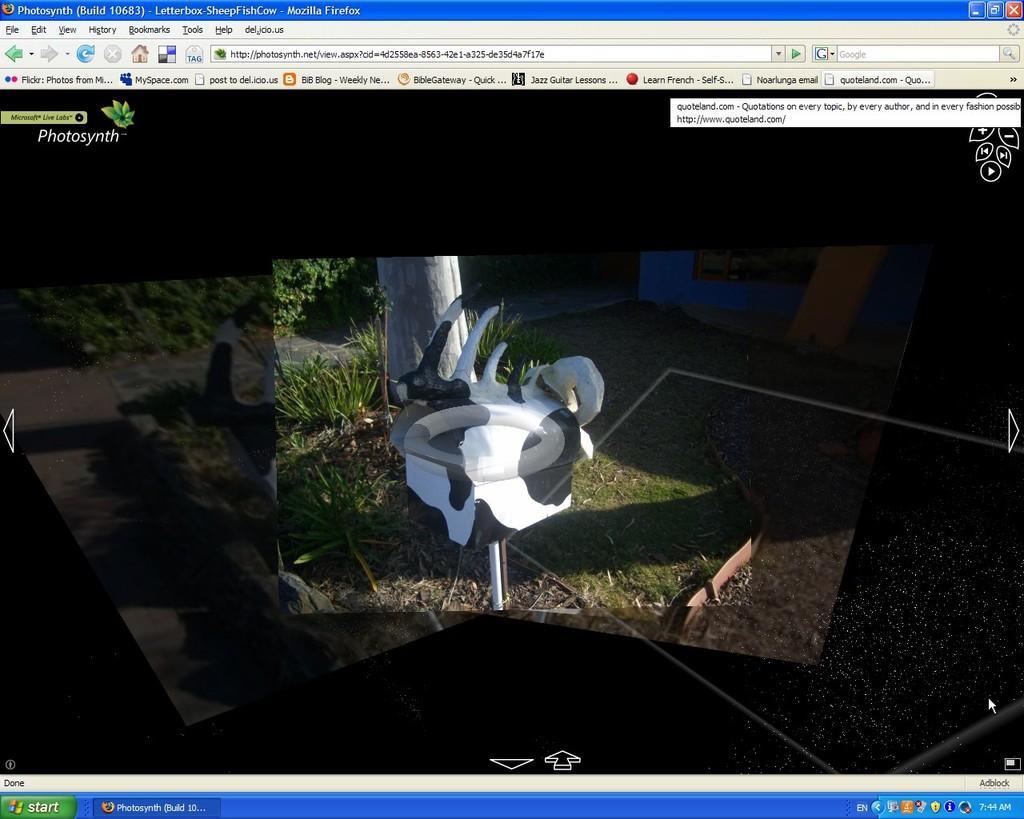Can you describe this image briefly? In this picture, we can see a screenshot of a web page. 